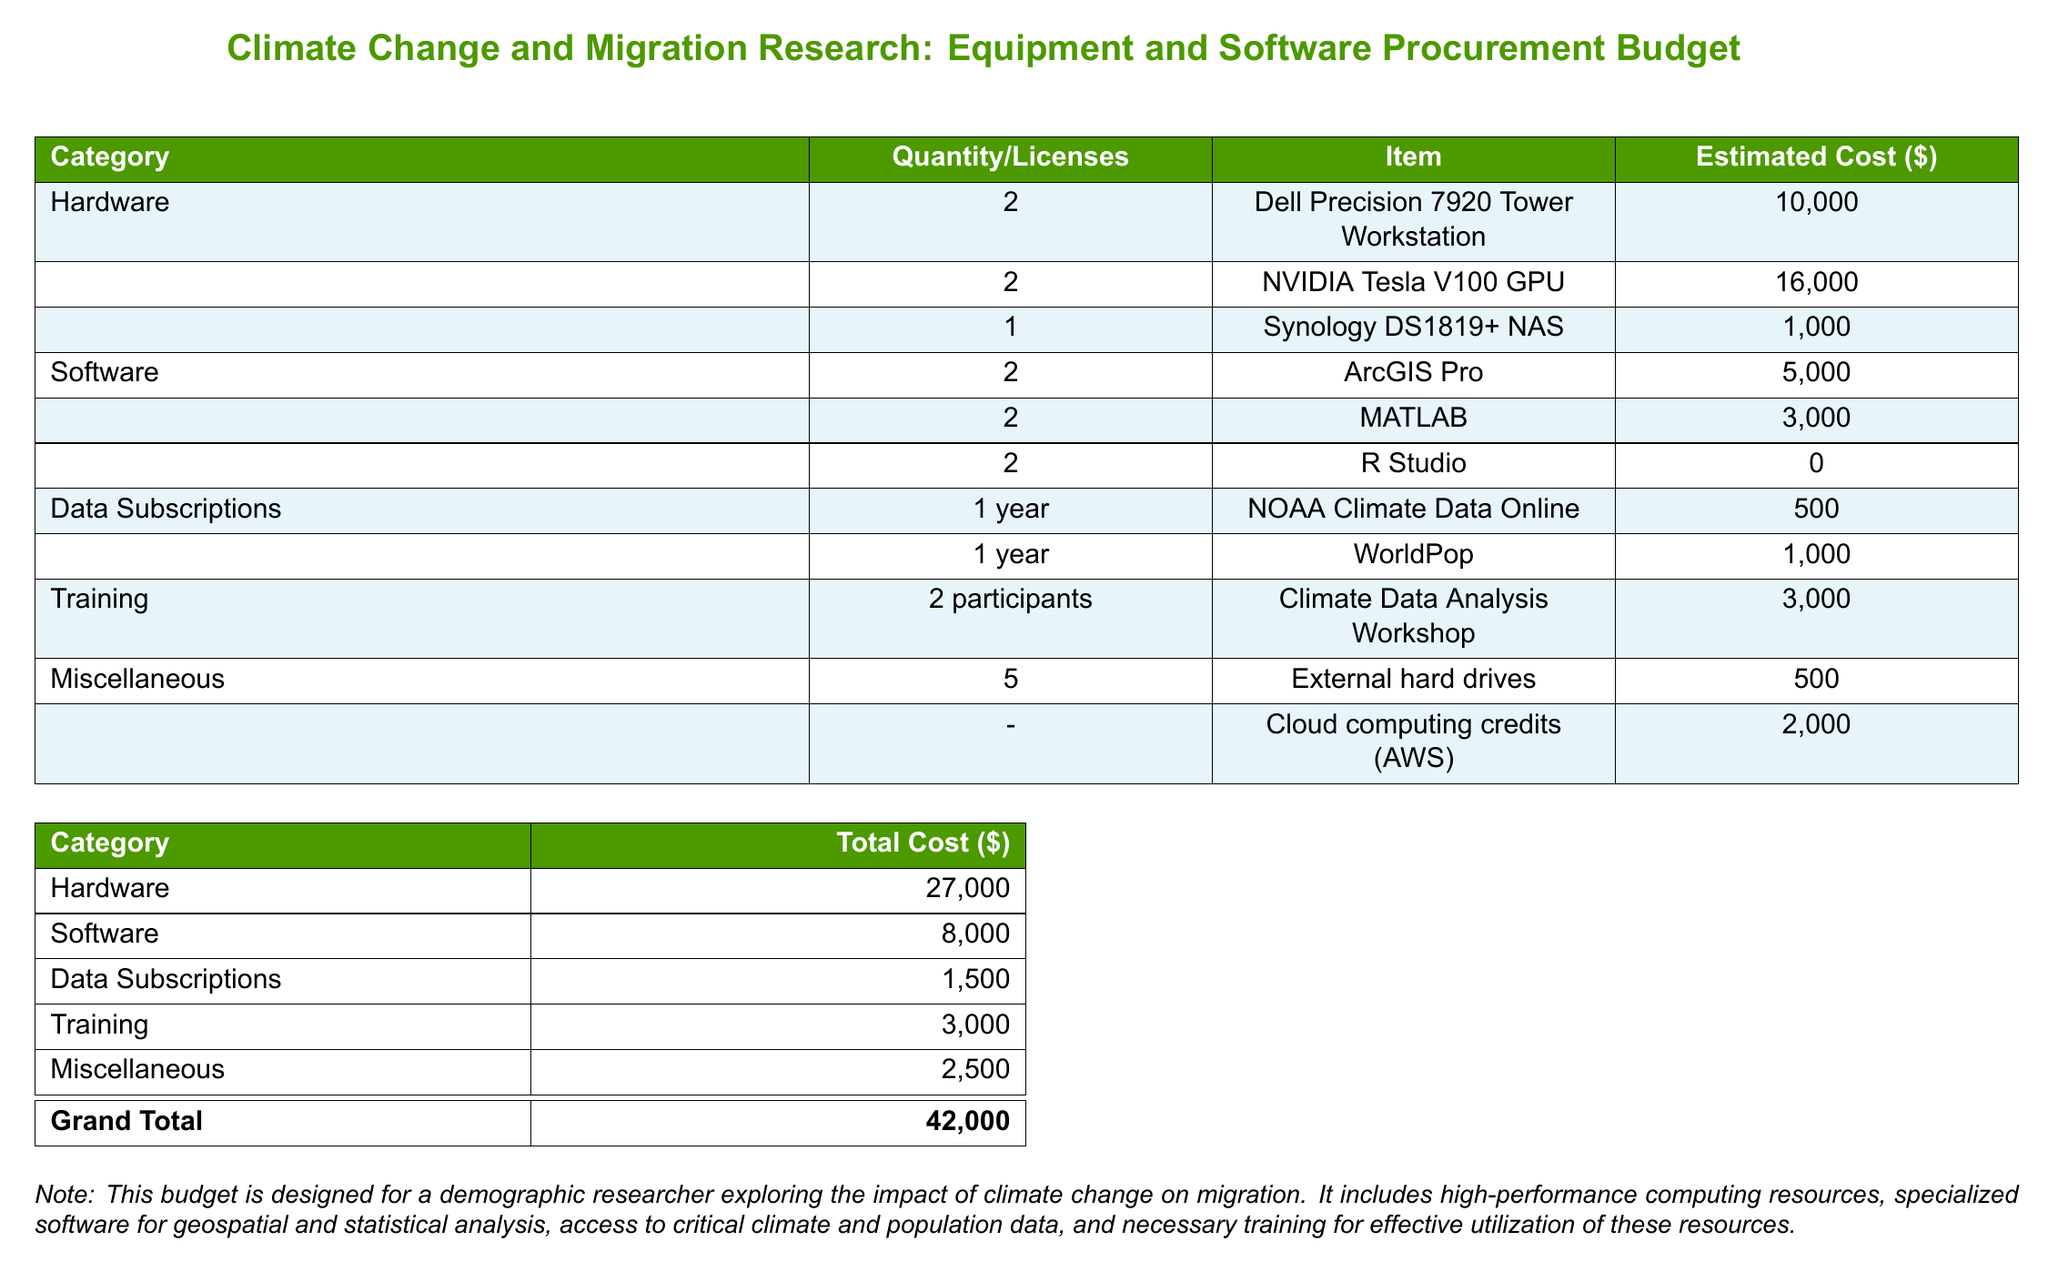What is the total estimated cost for hardware? The total estimated cost for hardware is presented as a separate line item in the budget table. The total for hardware is $27,000.
Answer: $27,000 How many NVIDIA Tesla V100 GPUs are listed? The number of NVIDIA Tesla V100 GPUs can be found in the hardware section of the budget, which states there are 2 units.
Answer: 2 What is the cost of ArcGIS Pro licenses? The cost of ArcGIS Pro licenses is detailed in the software section of the budget, where the total is listed as $5,000 for 2 licenses.
Answer: $5,000 What is the grand total of the budget? The grand total is calculated by summing up all the categories, which is indicated at the bottom of the budget. The grand total is $42,000.
Answer: $42,000 How many training participants are included? The number of training participants is specified in the training section of the budget, indicating there are 2 participants.
Answer: 2 What is the cost for cloud computing credits? The cost for cloud computing credits is mentioned in the miscellaneous section of the budget as $2,000.
Answer: $2,000 What software requires no cost? The budget lists specific software items, and one of them, R Studio, is marked with no cost.
Answer: R Studio What is the total cost for data subscriptions? The total cost for data subscriptions can be calculated from the items listed in that section, which adds up to $1,500.
Answer: $1,500 What kind of training is included in the budget? The type of training is described in the training section, specifying the "Climate Data Analysis Workshop" as the included training.
Answer: Climate Data Analysis Workshop 